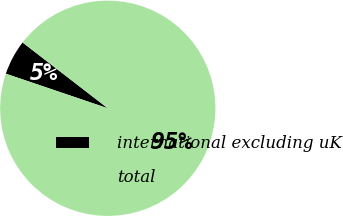Convert chart. <chart><loc_0><loc_0><loc_500><loc_500><pie_chart><fcel>international excluding uK<fcel>total<nl><fcel>5.26%<fcel>94.74%<nl></chart> 